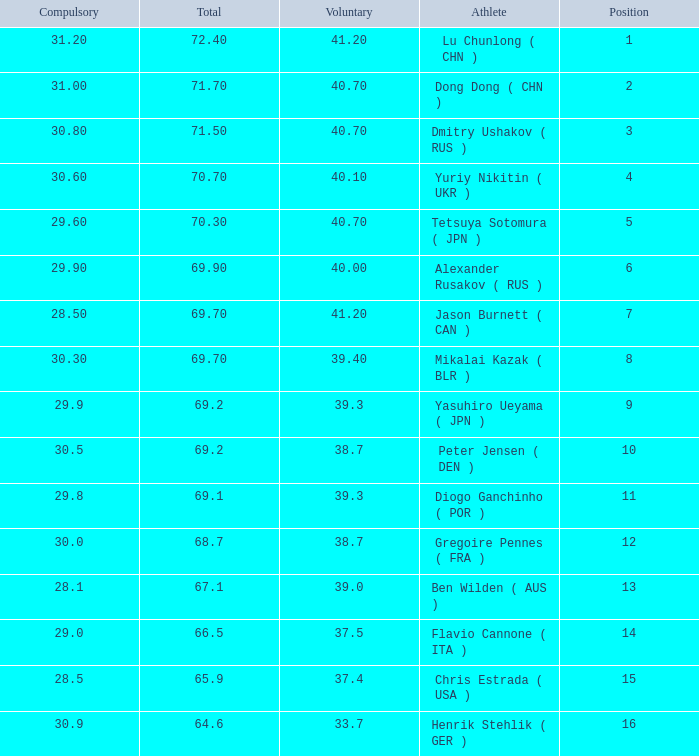What's the position that has a total less than 66.5m, a compulsory of 30.9 and voluntary less than 33.7? None. 